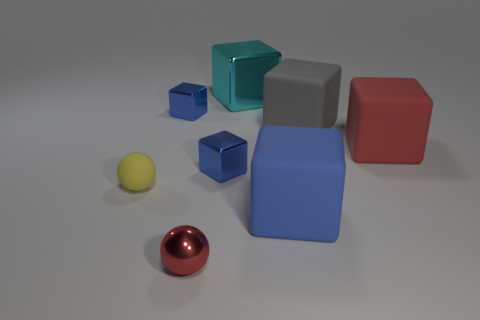How many blue blocks must be subtracted to get 1 blue blocks? 2 Subtract all green spheres. How many blue cubes are left? 3 Subtract all gray blocks. How many blocks are left? 5 Subtract all small cubes. How many cubes are left? 4 Subtract all red cubes. Subtract all yellow cylinders. How many cubes are left? 5 Add 1 big gray objects. How many objects exist? 9 Subtract all balls. How many objects are left? 6 Subtract 0 brown blocks. How many objects are left? 8 Subtract all big gray matte things. Subtract all big yellow things. How many objects are left? 7 Add 5 shiny spheres. How many shiny spheres are left? 6 